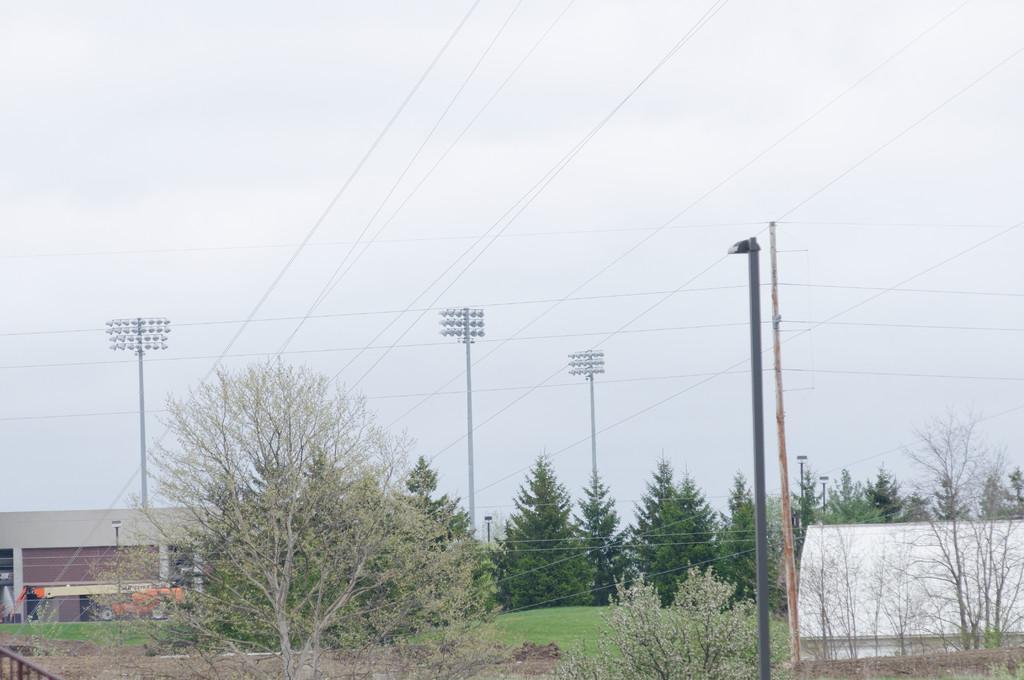Could you give a brief overview of what you see in this image? In this image I can see the trees. To the side there is a shed and I can see the vehicle in-front of the shed. There are many poles in the back. I can also see the sky in the back. 